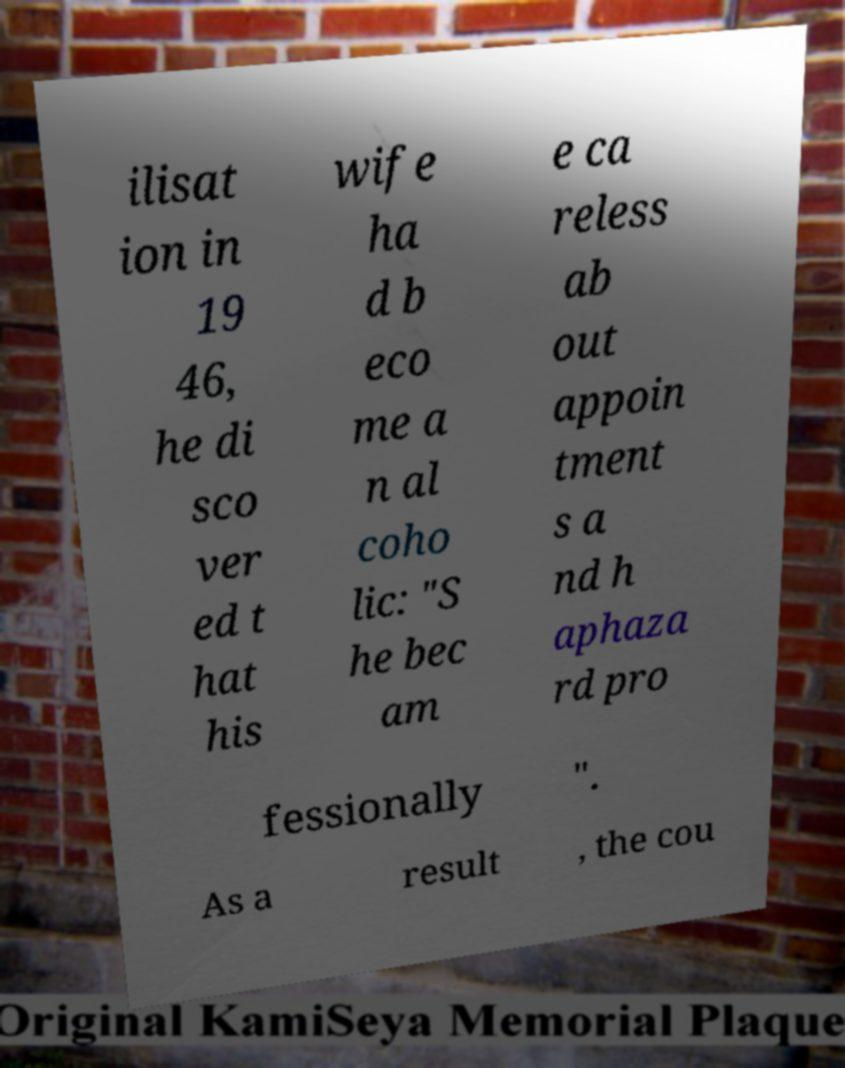What messages or text are displayed in this image? I need them in a readable, typed format. ilisat ion in 19 46, he di sco ver ed t hat his wife ha d b eco me a n al coho lic: "S he bec am e ca reless ab out appoin tment s a nd h aphaza rd pro fessionally ". As a result , the cou 